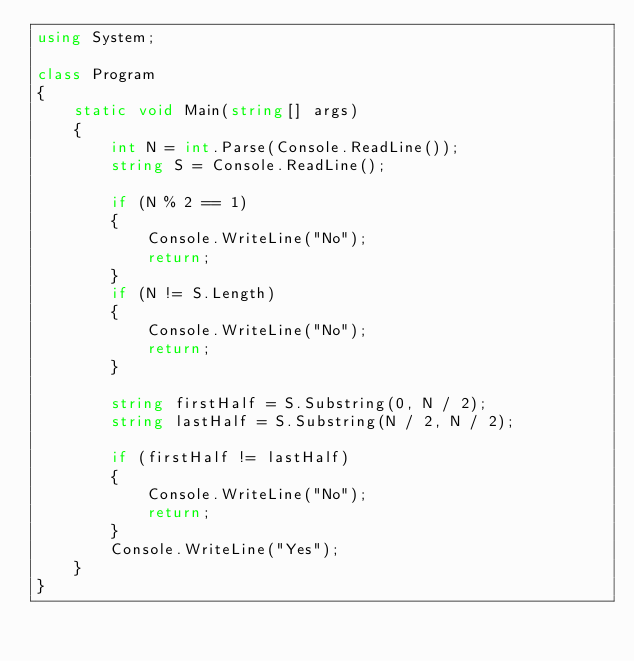<code> <loc_0><loc_0><loc_500><loc_500><_C#_>using System;

class Program
{
    static void Main(string[] args)
    {
        int N = int.Parse(Console.ReadLine());
        string S = Console.ReadLine();

        if (N % 2 == 1)
        {
            Console.WriteLine("No");
            return;
        }
        if (N != S.Length)
        {
            Console.WriteLine("No");
            return;
        }

        string firstHalf = S.Substring(0, N / 2);
        string lastHalf = S.Substring(N / 2, N / 2);

        if (firstHalf != lastHalf)
        {
            Console.WriteLine("No");
            return;
        }
        Console.WriteLine("Yes");
    }
}
</code> 